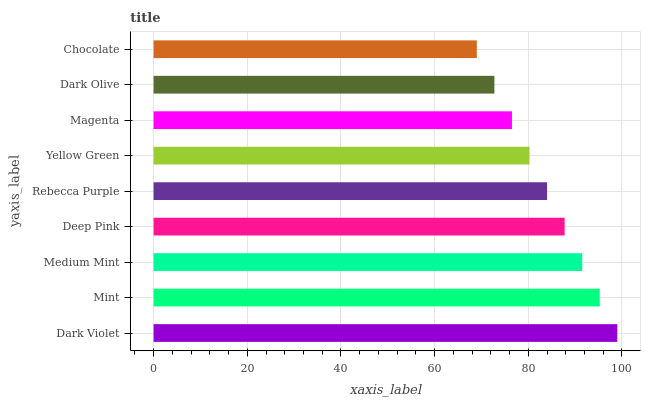Is Chocolate the minimum?
Answer yes or no. Yes. Is Dark Violet the maximum?
Answer yes or no. Yes. Is Mint the minimum?
Answer yes or no. No. Is Mint the maximum?
Answer yes or no. No. Is Dark Violet greater than Mint?
Answer yes or no. Yes. Is Mint less than Dark Violet?
Answer yes or no. Yes. Is Mint greater than Dark Violet?
Answer yes or no. No. Is Dark Violet less than Mint?
Answer yes or no. No. Is Rebecca Purple the high median?
Answer yes or no. Yes. Is Rebecca Purple the low median?
Answer yes or no. Yes. Is Magenta the high median?
Answer yes or no. No. Is Dark Olive the low median?
Answer yes or no. No. 